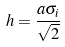<formula> <loc_0><loc_0><loc_500><loc_500>h = \frac { a \sigma _ { i } } { \sqrt { 2 } }</formula> 